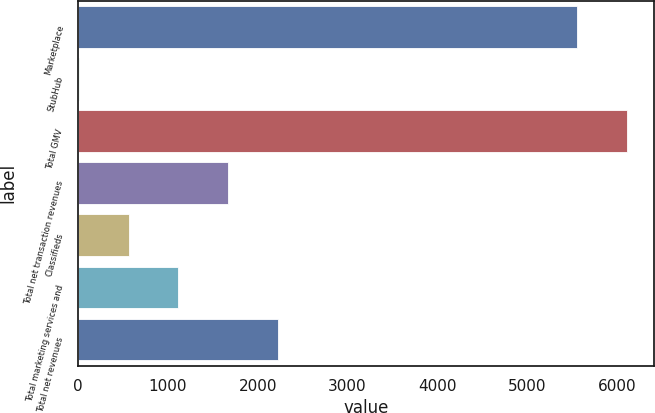<chart> <loc_0><loc_0><loc_500><loc_500><bar_chart><fcel>Marketplace<fcel>StubHub<fcel>Total GMV<fcel>Total net transaction revenues<fcel>Classifieds<fcel>Total marketing services and<fcel>Total net revenues<nl><fcel>5554<fcel>5<fcel>6109.4<fcel>1671.2<fcel>560.4<fcel>1115.8<fcel>2226.6<nl></chart> 